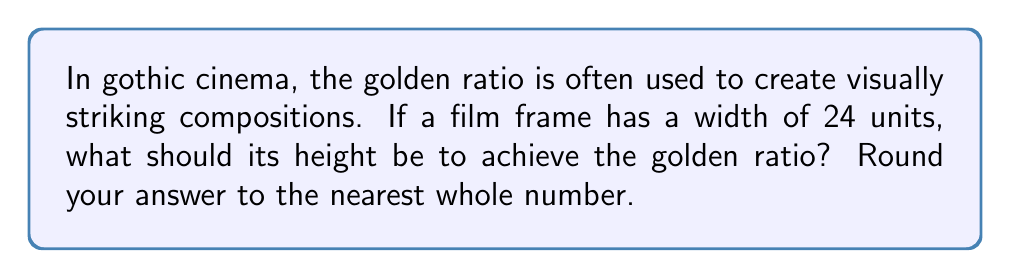Can you solve this math problem? To solve this problem, we'll follow these steps:

1) The golden ratio, denoted by φ (phi), is approximately 1.618033988749895.

2) In a rectangle with the golden ratio, the ratio of the longer side to the shorter side is φ.

3) We're given that the width is 24 units. Let's call the height h.

4) We can set up the equation:

   $$\frac{24}{h} = \phi$$

5) To solve for h, we multiply both sides by h:

   $$24 = \phi h$$

6) Now divide both sides by φ:

   $$\frac{24}{\phi} = h$$

7) Substituting the value of φ:

   $$h = \frac{24}{1.618033988749895}$$

8) Calculate:

   $$h ≈ 14.8323969741913$$

9) Rounding to the nearest whole number:

   $$h ≈ 15$$

Therefore, for a film frame with a width of 24 units to achieve the golden ratio, its height should be approximately 15 units.
Answer: 15 units 